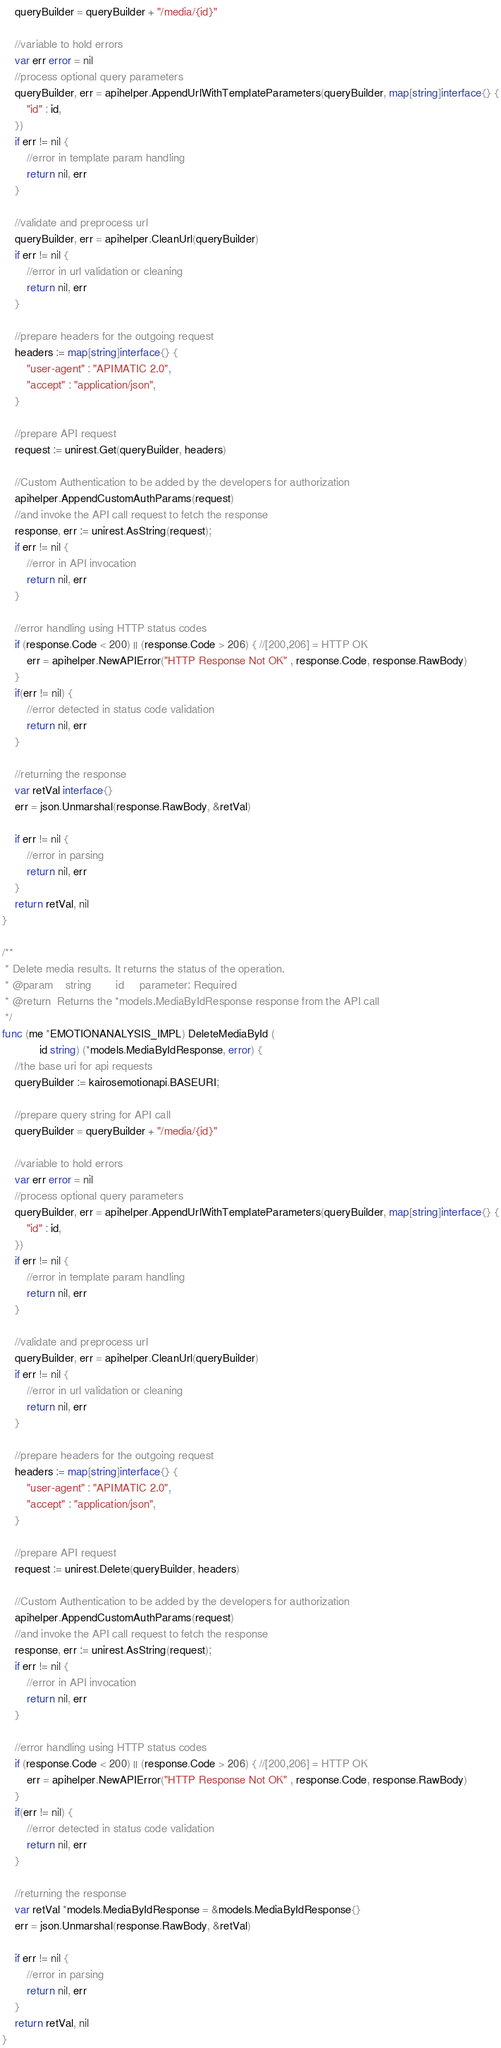<code> <loc_0><loc_0><loc_500><loc_500><_Go_>    queryBuilder = queryBuilder + "/media/{id}"

    //variable to hold errors
    var err error = nil
    //process optional query parameters
    queryBuilder, err = apihelper.AppendUrlWithTemplateParameters(queryBuilder, map[string]interface{} {
        "id" : id,
    }) 
    if err != nil {
        //error in template param handling
        return nil, err
    }

    //validate and preprocess url
    queryBuilder, err = apihelper.CleanUrl(queryBuilder)
    if err != nil {
        //error in url validation or cleaning
        return nil, err
    }

    //prepare headers for the outgoing request
    headers := map[string]interface{} {
        "user-agent" : "APIMATIC 2.0",
        "accept" : "application/json",
    }

    //prepare API request
    request := unirest.Get(queryBuilder, headers)

    //Custom Authentication to be added by the developers for authorization
    apihelper.AppendCustomAuthParams(request)
    //and invoke the API call request to fetch the response
    response, err := unirest.AsString(request);
    if err != nil {
        //error in API invocation
        return nil, err
    }

    //error handling using HTTP status codes
    if (response.Code < 200) || (response.Code > 206) { //[200,206] = HTTP OK
        err = apihelper.NewAPIError("HTTP Response Not OK" , response.Code, response.RawBody)
    }
    if(err != nil) {
        //error detected in status code validation
        return nil, err
    }
    
    //returning the response
    var retVal interface{}
    err = json.Unmarshal(response.RawBody, &retVal)

    if err != nil {
        //error in parsing
        return nil, err
    }
    return retVal, nil
}

/**
 * Delete media results. It returns the status of the operation.
 * @param    string        id     parameter: Required
 * @return	Returns the *models.MediaByIdResponse response from the API call
 */
func (me *EMOTIONANALYSIS_IMPL) DeleteMediaById (
            id string) (*models.MediaByIdResponse, error) {
    //the base uri for api requests
    queryBuilder := kairosemotionapi.BASEURI;
        
    //prepare query string for API call
    queryBuilder = queryBuilder + "/media/{id}"

    //variable to hold errors
    var err error = nil
    //process optional query parameters
    queryBuilder, err = apihelper.AppendUrlWithTemplateParameters(queryBuilder, map[string]interface{} {
        "id" : id,
    }) 
    if err != nil {
        //error in template param handling
        return nil, err
    }

    //validate and preprocess url
    queryBuilder, err = apihelper.CleanUrl(queryBuilder)
    if err != nil {
        //error in url validation or cleaning
        return nil, err
    }

    //prepare headers for the outgoing request
    headers := map[string]interface{} {
        "user-agent" : "APIMATIC 2.0",
        "accept" : "application/json",
    }

    //prepare API request
    request := unirest.Delete(queryBuilder, headers)

    //Custom Authentication to be added by the developers for authorization
    apihelper.AppendCustomAuthParams(request)
    //and invoke the API call request to fetch the response
    response, err := unirest.AsString(request);
    if err != nil {
        //error in API invocation
        return nil, err
    }

    //error handling using HTTP status codes
    if (response.Code < 200) || (response.Code > 206) { //[200,206] = HTTP OK
        err = apihelper.NewAPIError("HTTP Response Not OK" , response.Code, response.RawBody)
    }
    if(err != nil) {
        //error detected in status code validation
        return nil, err
    }
    
    //returning the response
    var retVal *models.MediaByIdResponse = &models.MediaByIdResponse{}
    err = json.Unmarshal(response.RawBody, &retVal)

    if err != nil {
        //error in parsing
        return nil, err
    }
    return retVal, nil
}

</code> 